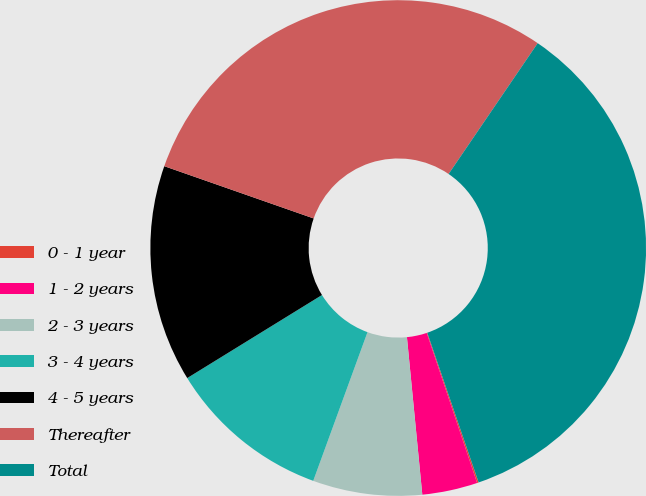Convert chart to OTSL. <chart><loc_0><loc_0><loc_500><loc_500><pie_chart><fcel>0 - 1 year<fcel>1 - 2 years<fcel>2 - 3 years<fcel>3 - 4 years<fcel>4 - 5 years<fcel>Thereafter<fcel>Total<nl><fcel>0.1%<fcel>3.61%<fcel>7.12%<fcel>10.64%<fcel>14.15%<fcel>29.16%<fcel>35.23%<nl></chart> 